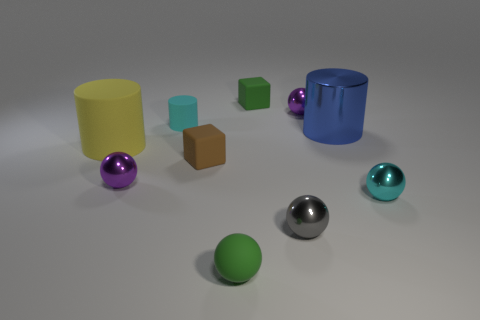Subtract all green balls. How many balls are left? 4 Subtract 1 spheres. How many spheres are left? 4 Subtract all green balls. How many balls are left? 4 Subtract all red balls. Subtract all gray cylinders. How many balls are left? 5 Subtract all cylinders. How many objects are left? 7 Subtract 1 blue cylinders. How many objects are left? 9 Subtract all tiny brown cylinders. Subtract all purple shiny objects. How many objects are left? 8 Add 4 blue things. How many blue things are left? 5 Add 6 large brown cylinders. How many large brown cylinders exist? 6 